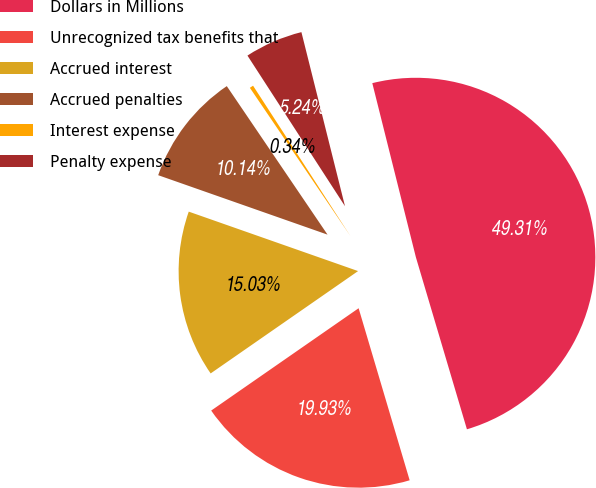Convert chart. <chart><loc_0><loc_0><loc_500><loc_500><pie_chart><fcel>Dollars in Millions<fcel>Unrecognized tax benefits that<fcel>Accrued interest<fcel>Accrued penalties<fcel>Interest expense<fcel>Penalty expense<nl><fcel>49.31%<fcel>19.93%<fcel>15.03%<fcel>10.14%<fcel>0.34%<fcel>5.24%<nl></chart> 